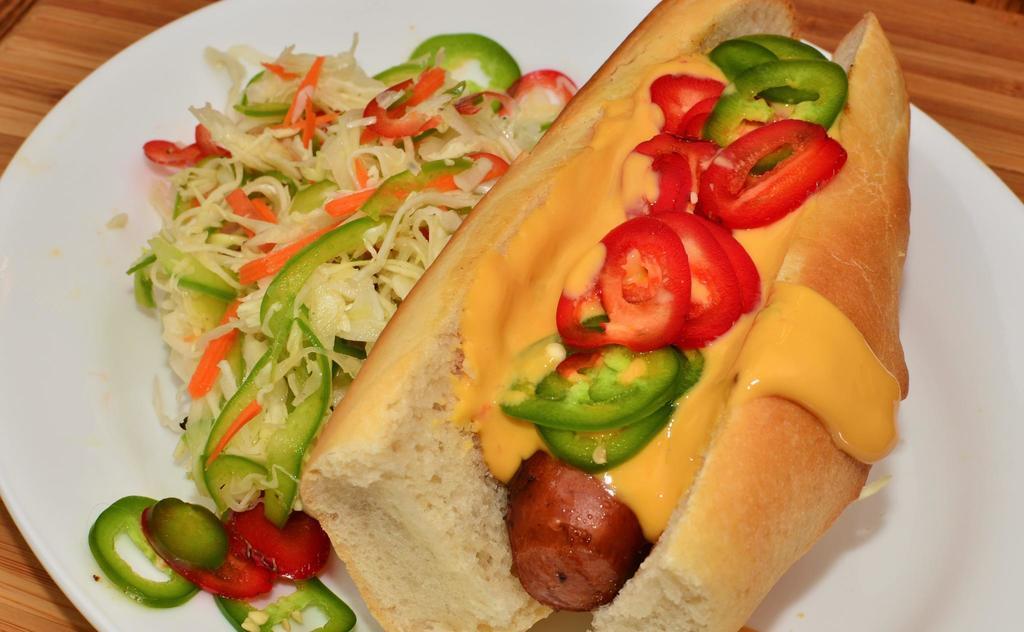In one or two sentences, can you explain what this image depicts? In this image we can see food items in a plate on the table. 